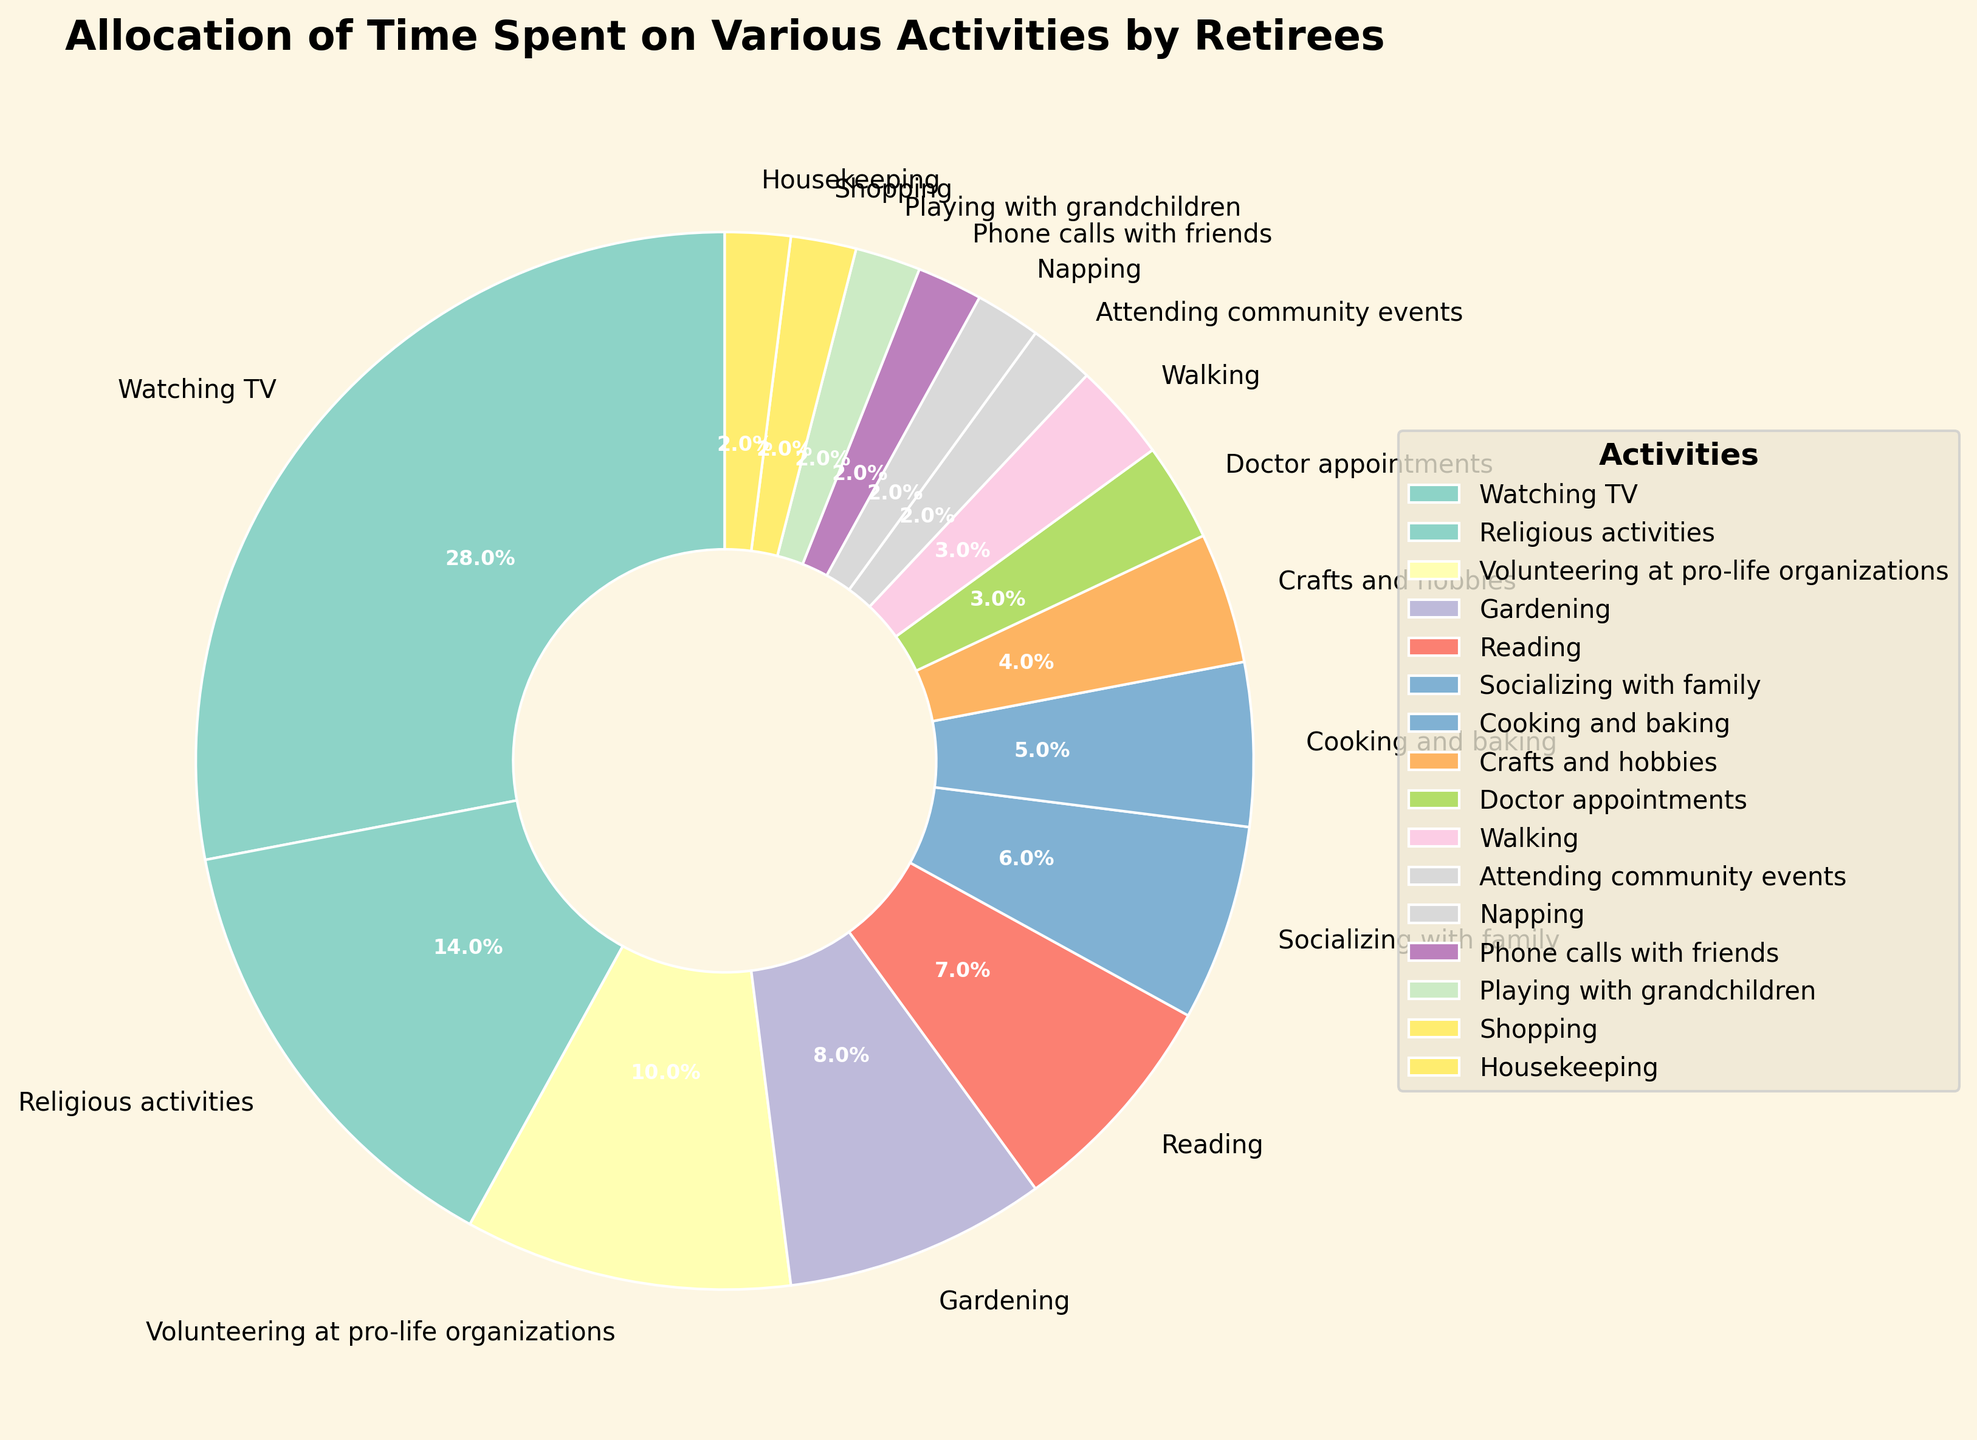Which activity takes up the most time according to the pie chart? The activity with the largest wedge, labeled “28 hours,” corresponds to “Watching TV.”
Answer: Watching TV How much total time is spent on religious activities and volunteering at pro-life organizations combined? According to the pie chart, “Religious activities” take up 14 hours and “Volunteering at pro-life organizations” takes up 10 hours. Adding them gives 14 + 10 = 24 hours.
Answer: 24 hours How does the time spent on gardening compare to the time spent reading? From the pie chart, “Gardening” takes up 8 hours, and “Reading” takes up 7 hours. 8 hours is greater than 7 hours.
Answer: Gardening is greater What fraction of the week is spent walking? The pie chart shows that 3 hours per week are spent walking. There are 168 hours in a week. The fraction is 3/168 which simplifies to 1/56.
Answer: 1/56 Is more time spent on socializing with family or on cooking and baking? According to the pie chart, 6 hours are spent socializing with family and 5 hours are spent cooking and baking. 6 is greater than 5.
Answer: Socializing with family What percentage of the week is spent on doctor appointments? The pie chart indicates that 3 hours per week are spent on doctor appointments. With 168 hours in a week, the percentage is (3/168) * 100 ≈ 1.8%.
Answer: 1.8% How much more time is spent watching TV than attending community events? According to the pie chart, 28 hours are spent watching TV and 2 hours are spent attending community events. The difference is 28 - 2 = 26 hours.
Answer: 26 hours Compare the time spent volunteering at pro-life organizations to the combined time spent on crafts and hobbies, napping, and phone calls with friends. The pie chart shows 10 hours are spent volunteering at pro-life organizations. Time spent on crafts and hobbies, napping, and phone calls with friends adds up to 4 + 2 + 2 = 8 hours. 10 hours is greater than 8 hours.
Answer: Volunteering is greater What is the visual difference between the wedges for socializing with family and playing with grandchildren? The wedge for “Socializing with family” is larger and is labeled “6 hours,” while the wedge for “Playing with grandchildren” is smaller and is labeled “2 hours.”
Answer: Socializing with family wedge is larger What activities occupy the smallest proportion of time? The pie chart shows that activities such as attending community events, napping, phone calls with friends, playing with grandchildren, shopping, and housekeeping each occupy 2 hours or less per week.
Answer: Several activities including attending community events, napping, phone calls with friends, playing with grandchildren, shopping, and housekeeping 